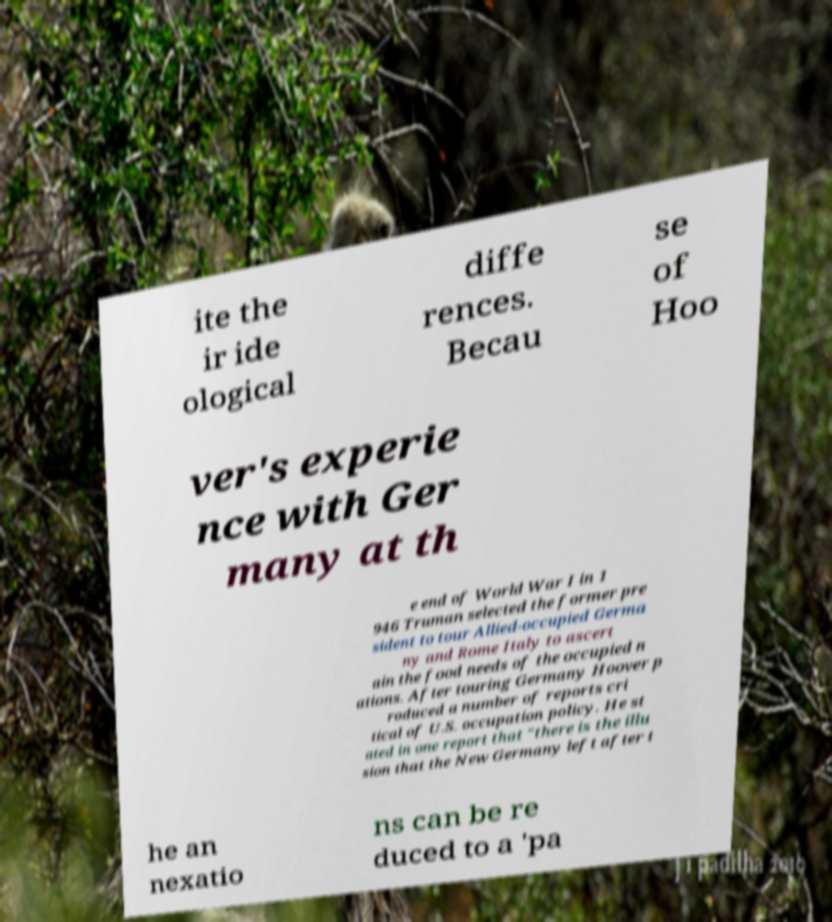I need the written content from this picture converted into text. Can you do that? ite the ir ide ological diffe rences. Becau se of Hoo ver's experie nce with Ger many at th e end of World War I in 1 946 Truman selected the former pre sident to tour Allied-occupied Germa ny and Rome Italy to ascert ain the food needs of the occupied n ations. After touring Germany Hoover p roduced a number of reports cri tical of U.S. occupation policy. He st ated in one report that "there is the illu sion that the New Germany left after t he an nexatio ns can be re duced to a 'pa 